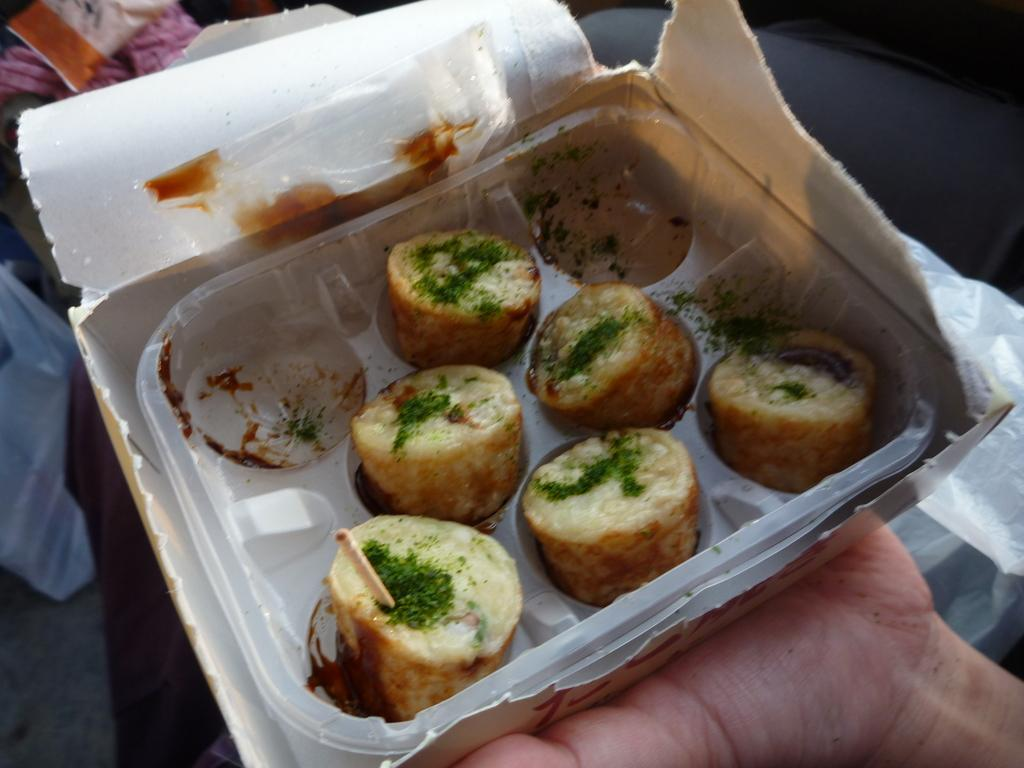What is present in the image? There is a person in the image. What is the person holding? The person is holding a food item. How is the food item contained? The food item is in a box. What type of ship can be seen in the image? There is no ship present in the image. How does the beast help the person in the image? There is no beast present in the image, so it cannot help the person. 